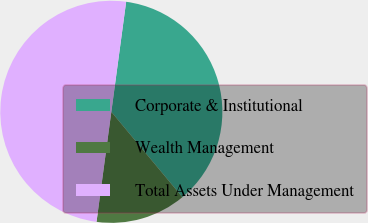Convert chart. <chart><loc_0><loc_0><loc_500><loc_500><pie_chart><fcel>Corporate & Institutional<fcel>Wealth Management<fcel>Total Assets Under Management<nl><fcel>36.82%<fcel>13.18%<fcel>50.0%<nl></chart> 